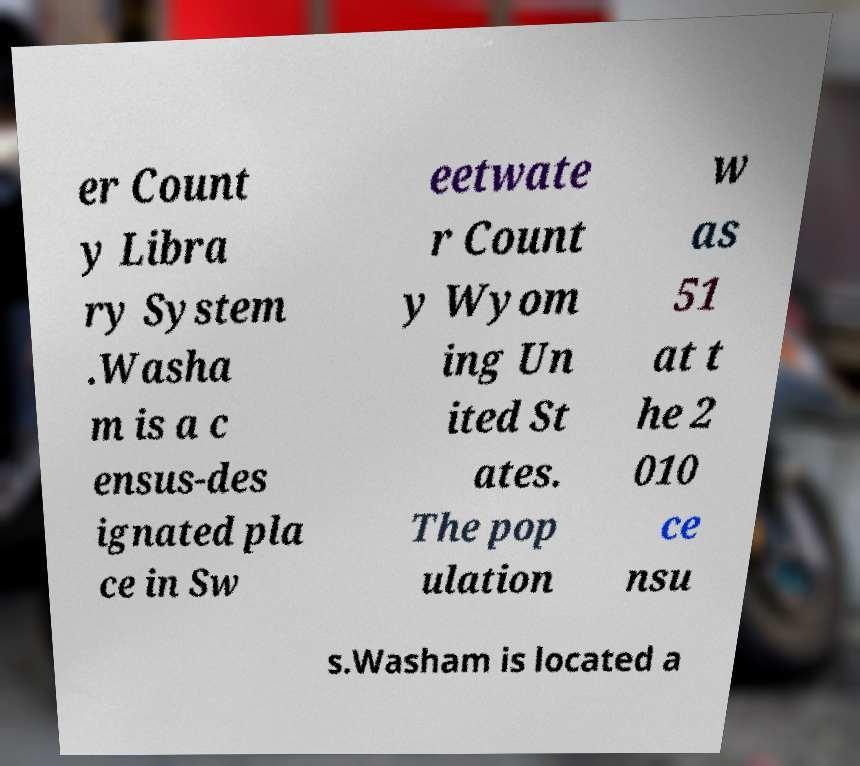There's text embedded in this image that I need extracted. Can you transcribe it verbatim? er Count y Libra ry System .Washa m is a c ensus-des ignated pla ce in Sw eetwate r Count y Wyom ing Un ited St ates. The pop ulation w as 51 at t he 2 010 ce nsu s.Washam is located a 